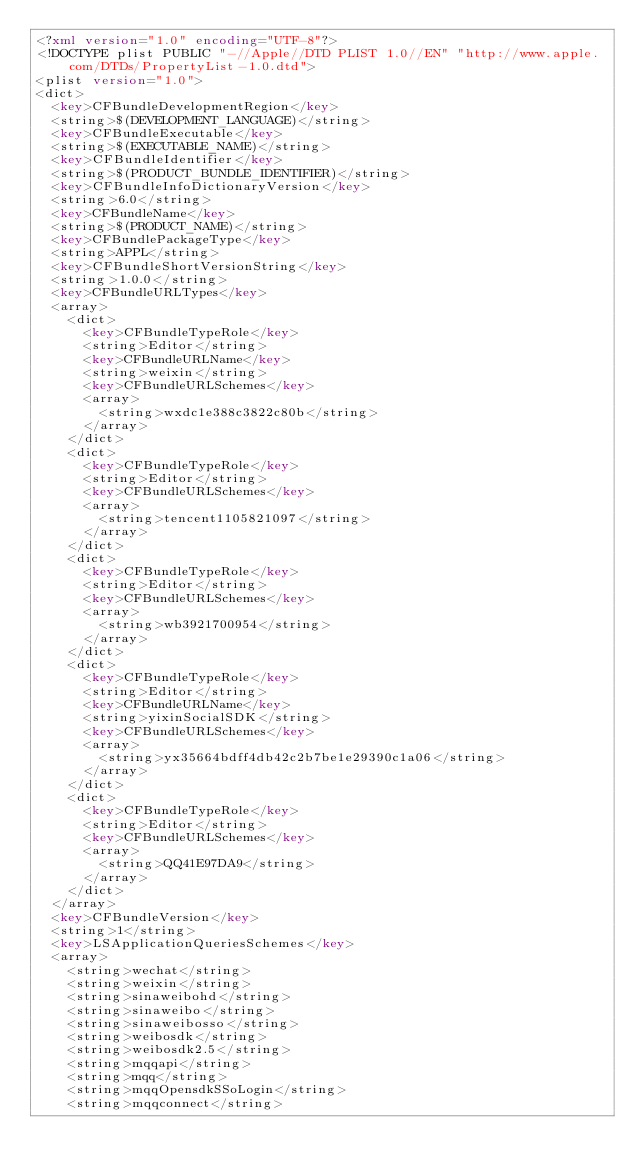Convert code to text. <code><loc_0><loc_0><loc_500><loc_500><_XML_><?xml version="1.0" encoding="UTF-8"?>
<!DOCTYPE plist PUBLIC "-//Apple//DTD PLIST 1.0//EN" "http://www.apple.com/DTDs/PropertyList-1.0.dtd">
<plist version="1.0">
<dict>
	<key>CFBundleDevelopmentRegion</key>
	<string>$(DEVELOPMENT_LANGUAGE)</string>
	<key>CFBundleExecutable</key>
	<string>$(EXECUTABLE_NAME)</string>
	<key>CFBundleIdentifier</key>
	<string>$(PRODUCT_BUNDLE_IDENTIFIER)</string>
	<key>CFBundleInfoDictionaryVersion</key>
	<string>6.0</string>
	<key>CFBundleName</key>
	<string>$(PRODUCT_NAME)</string>
	<key>CFBundlePackageType</key>
	<string>APPL</string>
	<key>CFBundleShortVersionString</key>
	<string>1.0.0</string>
	<key>CFBundleURLTypes</key>
	<array>
		<dict>
			<key>CFBundleTypeRole</key>
			<string>Editor</string>
			<key>CFBundleURLName</key>
			<string>weixin</string>
			<key>CFBundleURLSchemes</key>
			<array>
				<string>wxdc1e388c3822c80b</string>
			</array>
		</dict>
		<dict>
			<key>CFBundleTypeRole</key>
			<string>Editor</string>
			<key>CFBundleURLSchemes</key>
			<array>
				<string>tencent1105821097</string>
			</array>
		</dict>
		<dict>
			<key>CFBundleTypeRole</key>
			<string>Editor</string>
			<key>CFBundleURLSchemes</key>
			<array>
				<string>wb3921700954</string>
			</array>
		</dict>
		<dict>
			<key>CFBundleTypeRole</key>
			<string>Editor</string>
			<key>CFBundleURLName</key>
			<string>yixinSocialSDK</string>
			<key>CFBundleURLSchemes</key>
			<array>
				<string>yx35664bdff4db42c2b7be1e29390c1a06</string>
			</array>
		</dict>
		<dict>
			<key>CFBundleTypeRole</key>
			<string>Editor</string>
			<key>CFBundleURLSchemes</key>
			<array>
				<string>QQ41E97DA9</string>
			</array>
		</dict>
	</array>
	<key>CFBundleVersion</key>
	<string>1</string>
	<key>LSApplicationQueriesSchemes</key>
	<array>
		<string>wechat</string>
		<string>weixin</string>
		<string>sinaweibohd</string>
		<string>sinaweibo</string>
		<string>sinaweibosso</string>
		<string>weibosdk</string>
		<string>weibosdk2.5</string>
		<string>mqqapi</string>
		<string>mqq</string>
		<string>mqqOpensdkSSoLogin</string>
		<string>mqqconnect</string></code> 